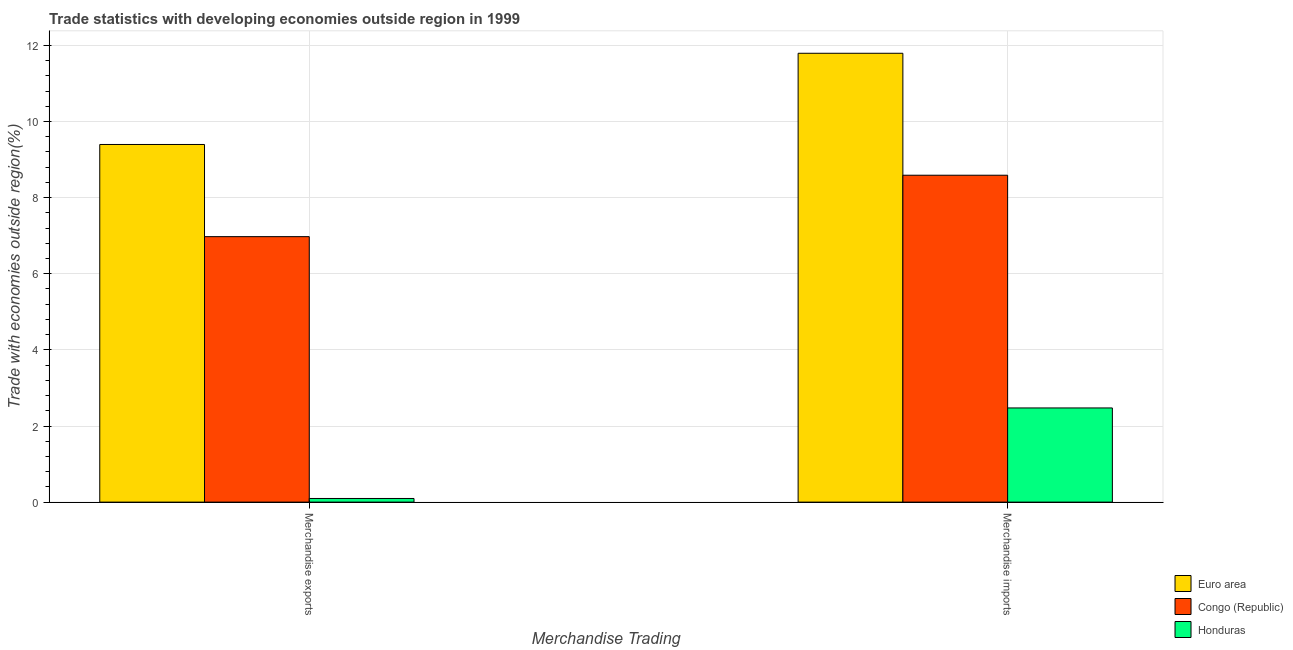How many groups of bars are there?
Give a very brief answer. 2. Are the number of bars on each tick of the X-axis equal?
Make the answer very short. Yes. How many bars are there on the 2nd tick from the left?
Offer a very short reply. 3. What is the merchandise exports in Congo (Republic)?
Offer a very short reply. 6.98. Across all countries, what is the maximum merchandise imports?
Offer a very short reply. 11.79. Across all countries, what is the minimum merchandise imports?
Provide a short and direct response. 2.47. In which country was the merchandise exports maximum?
Provide a succinct answer. Euro area. In which country was the merchandise exports minimum?
Your response must be concise. Honduras. What is the total merchandise exports in the graph?
Provide a short and direct response. 16.47. What is the difference between the merchandise exports in Congo (Republic) and that in Euro area?
Provide a succinct answer. -2.42. What is the difference between the merchandise exports in Honduras and the merchandise imports in Euro area?
Your answer should be compact. -11.7. What is the average merchandise exports per country?
Give a very brief answer. 5.49. What is the difference between the merchandise exports and merchandise imports in Congo (Republic)?
Ensure brevity in your answer.  -1.61. What is the ratio of the merchandise imports in Congo (Republic) to that in Euro area?
Provide a short and direct response. 0.73. In how many countries, is the merchandise imports greater than the average merchandise imports taken over all countries?
Provide a succinct answer. 2. What does the 2nd bar from the left in Merchandise imports represents?
Make the answer very short. Congo (Republic). What does the 1st bar from the right in Merchandise imports represents?
Provide a succinct answer. Honduras. How many countries are there in the graph?
Your response must be concise. 3. Are the values on the major ticks of Y-axis written in scientific E-notation?
Ensure brevity in your answer.  No. Does the graph contain any zero values?
Give a very brief answer. No. How many legend labels are there?
Your response must be concise. 3. How are the legend labels stacked?
Your answer should be compact. Vertical. What is the title of the graph?
Make the answer very short. Trade statistics with developing economies outside region in 1999. What is the label or title of the X-axis?
Your answer should be very brief. Merchandise Trading. What is the label or title of the Y-axis?
Provide a short and direct response. Trade with economies outside region(%). What is the Trade with economies outside region(%) of Euro area in Merchandise exports?
Provide a succinct answer. 9.4. What is the Trade with economies outside region(%) in Congo (Republic) in Merchandise exports?
Give a very brief answer. 6.98. What is the Trade with economies outside region(%) in Honduras in Merchandise exports?
Offer a very short reply. 0.1. What is the Trade with economies outside region(%) of Euro area in Merchandise imports?
Keep it short and to the point. 11.79. What is the Trade with economies outside region(%) in Congo (Republic) in Merchandise imports?
Your answer should be compact. 8.59. What is the Trade with economies outside region(%) of Honduras in Merchandise imports?
Keep it short and to the point. 2.47. Across all Merchandise Trading, what is the maximum Trade with economies outside region(%) of Euro area?
Your answer should be compact. 11.79. Across all Merchandise Trading, what is the maximum Trade with economies outside region(%) of Congo (Republic)?
Your response must be concise. 8.59. Across all Merchandise Trading, what is the maximum Trade with economies outside region(%) in Honduras?
Provide a succinct answer. 2.47. Across all Merchandise Trading, what is the minimum Trade with economies outside region(%) in Euro area?
Your answer should be very brief. 9.4. Across all Merchandise Trading, what is the minimum Trade with economies outside region(%) of Congo (Republic)?
Your answer should be very brief. 6.98. Across all Merchandise Trading, what is the minimum Trade with economies outside region(%) in Honduras?
Your answer should be very brief. 0.1. What is the total Trade with economies outside region(%) in Euro area in the graph?
Your answer should be compact. 21.19. What is the total Trade with economies outside region(%) in Congo (Republic) in the graph?
Keep it short and to the point. 15.56. What is the total Trade with economies outside region(%) of Honduras in the graph?
Your answer should be compact. 2.57. What is the difference between the Trade with economies outside region(%) of Euro area in Merchandise exports and that in Merchandise imports?
Offer a terse response. -2.4. What is the difference between the Trade with economies outside region(%) in Congo (Republic) in Merchandise exports and that in Merchandise imports?
Make the answer very short. -1.61. What is the difference between the Trade with economies outside region(%) of Honduras in Merchandise exports and that in Merchandise imports?
Your response must be concise. -2.38. What is the difference between the Trade with economies outside region(%) of Euro area in Merchandise exports and the Trade with economies outside region(%) of Congo (Republic) in Merchandise imports?
Offer a terse response. 0.81. What is the difference between the Trade with economies outside region(%) in Euro area in Merchandise exports and the Trade with economies outside region(%) in Honduras in Merchandise imports?
Your answer should be very brief. 6.92. What is the difference between the Trade with economies outside region(%) of Congo (Republic) in Merchandise exports and the Trade with economies outside region(%) of Honduras in Merchandise imports?
Provide a succinct answer. 4.5. What is the average Trade with economies outside region(%) of Euro area per Merchandise Trading?
Keep it short and to the point. 10.6. What is the average Trade with economies outside region(%) of Congo (Republic) per Merchandise Trading?
Keep it short and to the point. 7.78. What is the average Trade with economies outside region(%) in Honduras per Merchandise Trading?
Your answer should be very brief. 1.29. What is the difference between the Trade with economies outside region(%) of Euro area and Trade with economies outside region(%) of Congo (Republic) in Merchandise exports?
Your answer should be very brief. 2.42. What is the difference between the Trade with economies outside region(%) of Euro area and Trade with economies outside region(%) of Honduras in Merchandise exports?
Your answer should be compact. 9.3. What is the difference between the Trade with economies outside region(%) in Congo (Republic) and Trade with economies outside region(%) in Honduras in Merchandise exports?
Give a very brief answer. 6.88. What is the difference between the Trade with economies outside region(%) in Euro area and Trade with economies outside region(%) in Congo (Republic) in Merchandise imports?
Make the answer very short. 3.2. What is the difference between the Trade with economies outside region(%) of Euro area and Trade with economies outside region(%) of Honduras in Merchandise imports?
Keep it short and to the point. 9.32. What is the difference between the Trade with economies outside region(%) of Congo (Republic) and Trade with economies outside region(%) of Honduras in Merchandise imports?
Keep it short and to the point. 6.11. What is the ratio of the Trade with economies outside region(%) in Euro area in Merchandise exports to that in Merchandise imports?
Offer a very short reply. 0.8. What is the ratio of the Trade with economies outside region(%) of Congo (Republic) in Merchandise exports to that in Merchandise imports?
Your answer should be very brief. 0.81. What is the ratio of the Trade with economies outside region(%) of Honduras in Merchandise exports to that in Merchandise imports?
Keep it short and to the point. 0.04. What is the difference between the highest and the second highest Trade with economies outside region(%) in Euro area?
Keep it short and to the point. 2.4. What is the difference between the highest and the second highest Trade with economies outside region(%) of Congo (Republic)?
Make the answer very short. 1.61. What is the difference between the highest and the second highest Trade with economies outside region(%) in Honduras?
Offer a terse response. 2.38. What is the difference between the highest and the lowest Trade with economies outside region(%) of Euro area?
Provide a succinct answer. 2.4. What is the difference between the highest and the lowest Trade with economies outside region(%) in Congo (Republic)?
Offer a very short reply. 1.61. What is the difference between the highest and the lowest Trade with economies outside region(%) in Honduras?
Give a very brief answer. 2.38. 